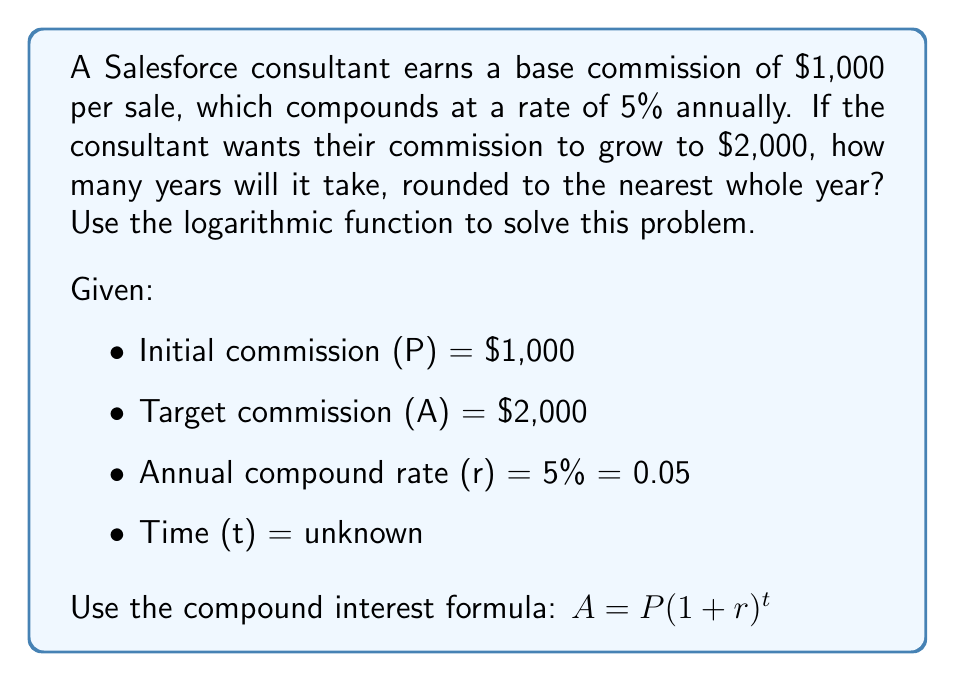Solve this math problem. Let's solve this step-by-step using logarithms:

1) Start with the compound interest formula:
   $A = P(1 + r)^t$

2) Substitute the known values:
   $2000 = 1000(1 + 0.05)^t$

3) Simplify:
   $2 = (1.05)^t$

4) Take the natural logarithm of both sides:
   $\ln(2) = \ln((1.05)^t)$

5) Use the logarithm property $\ln(x^n) = n\ln(x)$:
   $\ln(2) = t\ln(1.05)$

6) Solve for t:
   $t = \frac{\ln(2)}{\ln(1.05)}$

7) Calculate:
   $t = \frac{0.6931471806}{0.0487901142} \approx 14.2067$

8) Round to the nearest whole year:
   $t \approx 14$ years
Answer: 14 years 